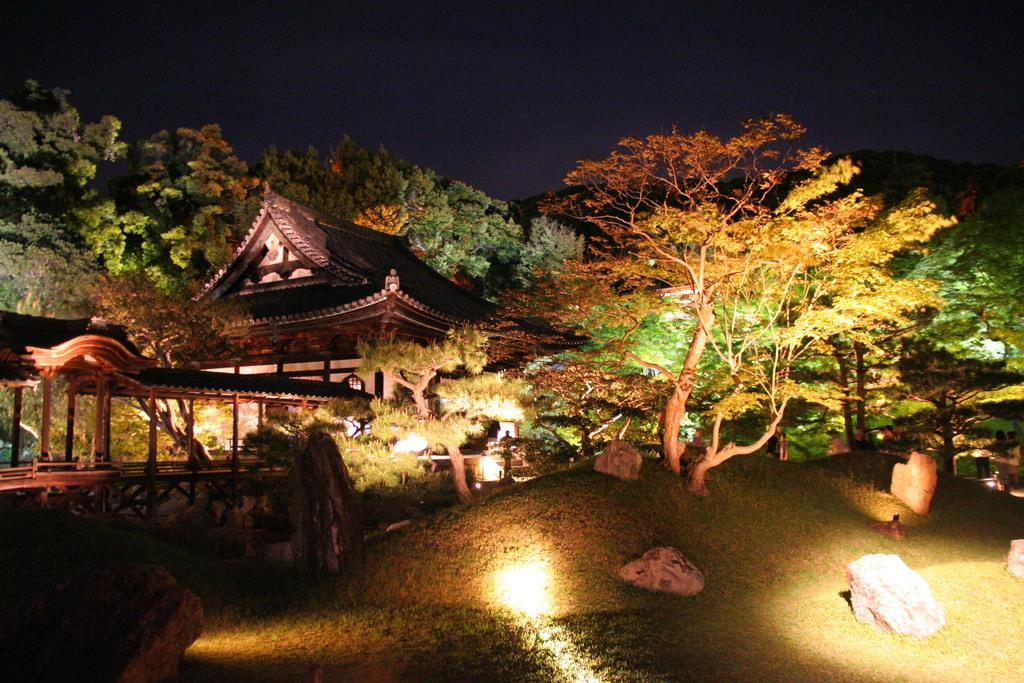What type of vegetation is present in the front of the image? There is grass on the ground in the front of the image. What else can be seen in the front of the image besides grass? There are stones visible in the front of the image. What is visible in the background of the image? There are trees and a house in the background of the image. Are there any additional structures or objects in the background? Yes, there is a tent in the background of the image. What time of day is it, as indicated by the position of the hour on the tent in the image? There is no hour or clock present on the tent in the image, so it is not possible to determine the time of day. What type of nail is being used to hold the tent in place in the image? There are no nails visible in the image, and the tent appears to be standing without any visible support. 